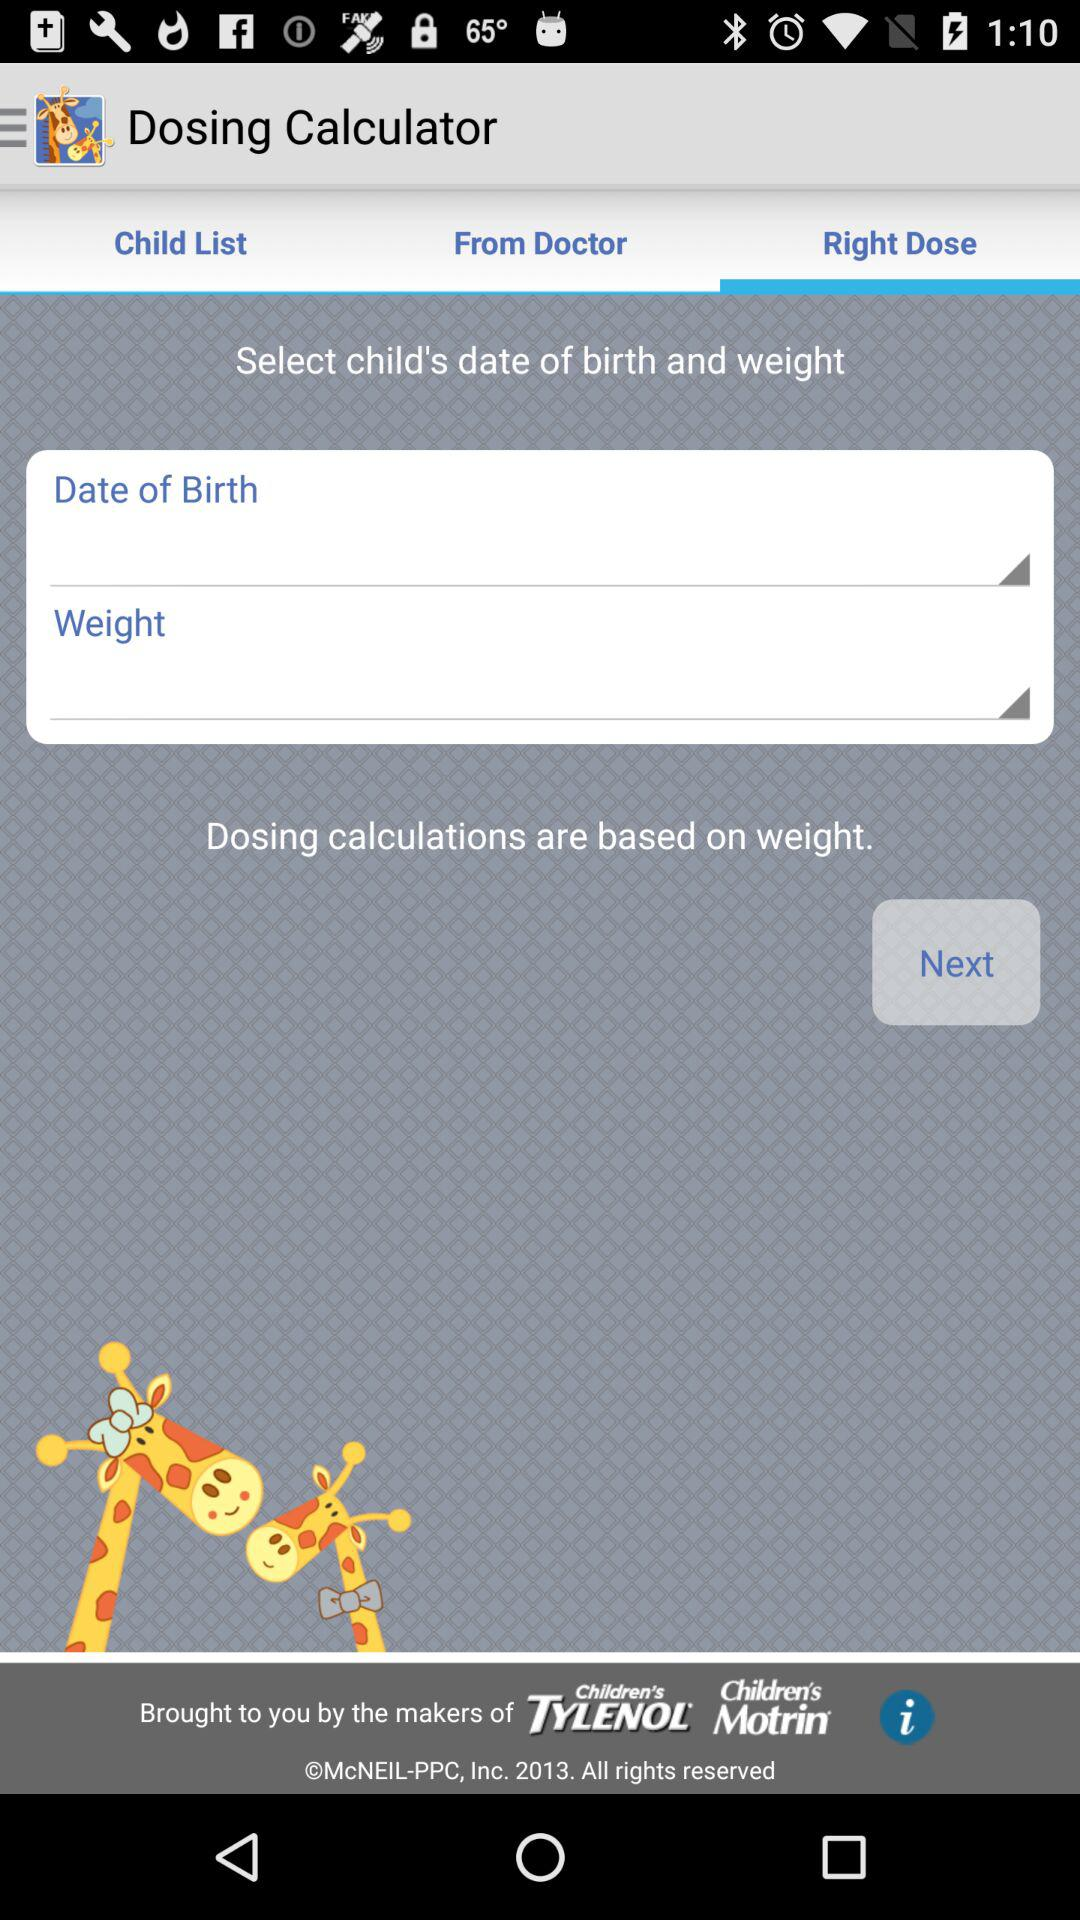How much does the user weigh?
When the provided information is insufficient, respond with <no answer>. <no answer> 